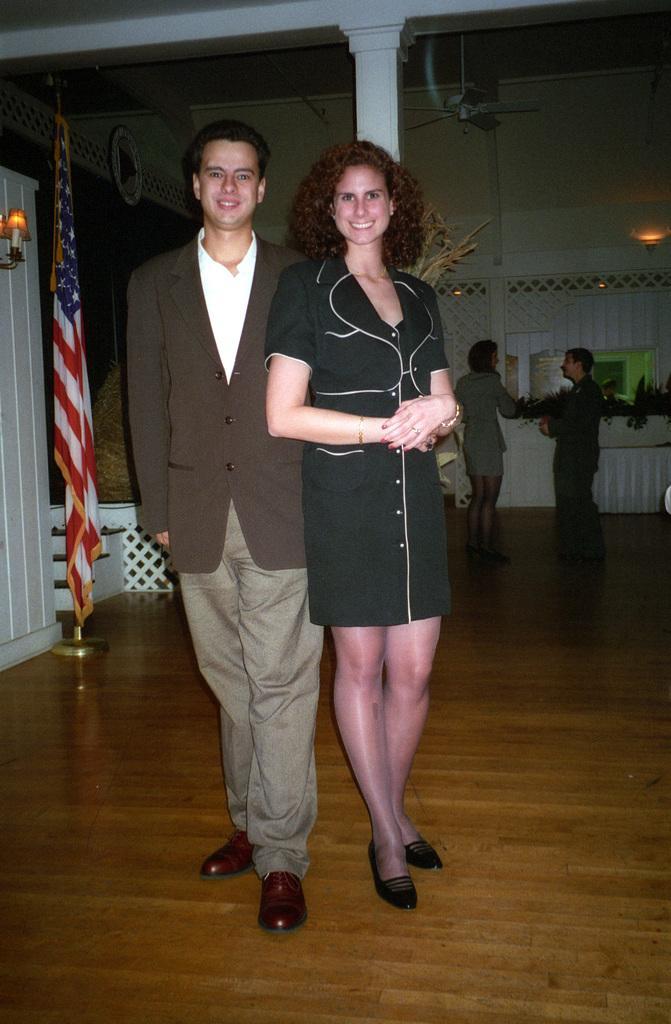Describe this image in one or two sentences. In this image we can see two persons on the floor, behind them, we can see a light attached to the shelf, a flag, two persons, lights, plants, ceiling fans, a pillar and a small wall. 